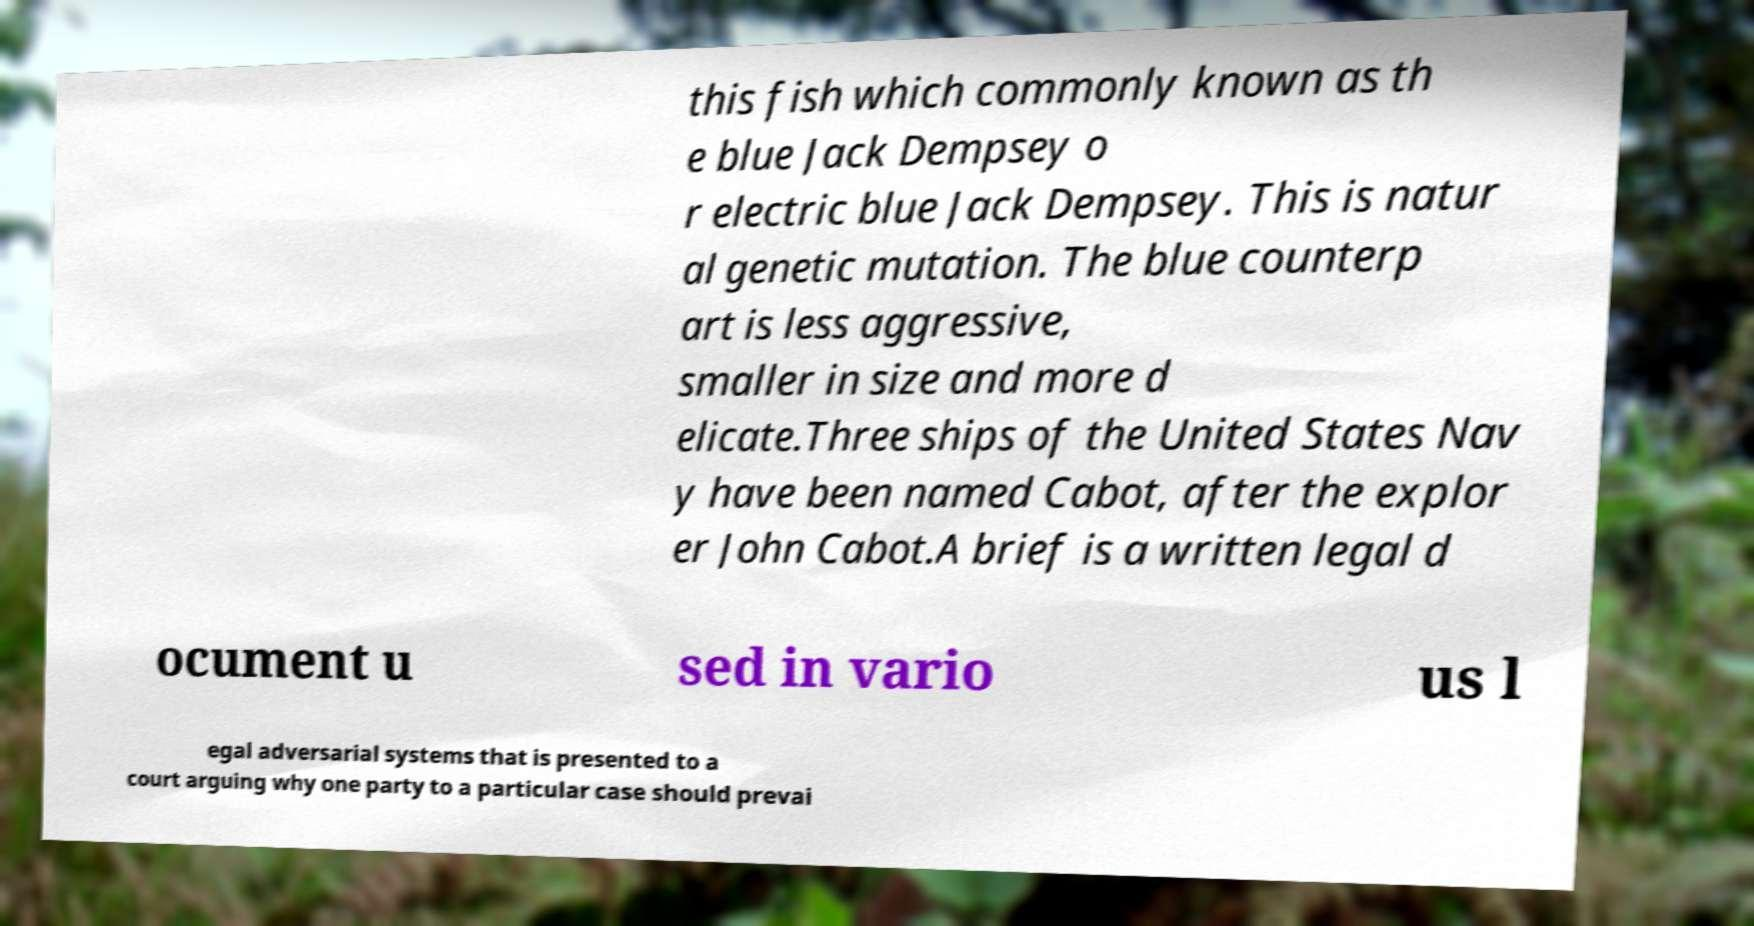I need the written content from this picture converted into text. Can you do that? this fish which commonly known as th e blue Jack Dempsey o r electric blue Jack Dempsey. This is natur al genetic mutation. The blue counterp art is less aggressive, smaller in size and more d elicate.Three ships of the United States Nav y have been named Cabot, after the explor er John Cabot.A brief is a written legal d ocument u sed in vario us l egal adversarial systems that is presented to a court arguing why one party to a particular case should prevai 